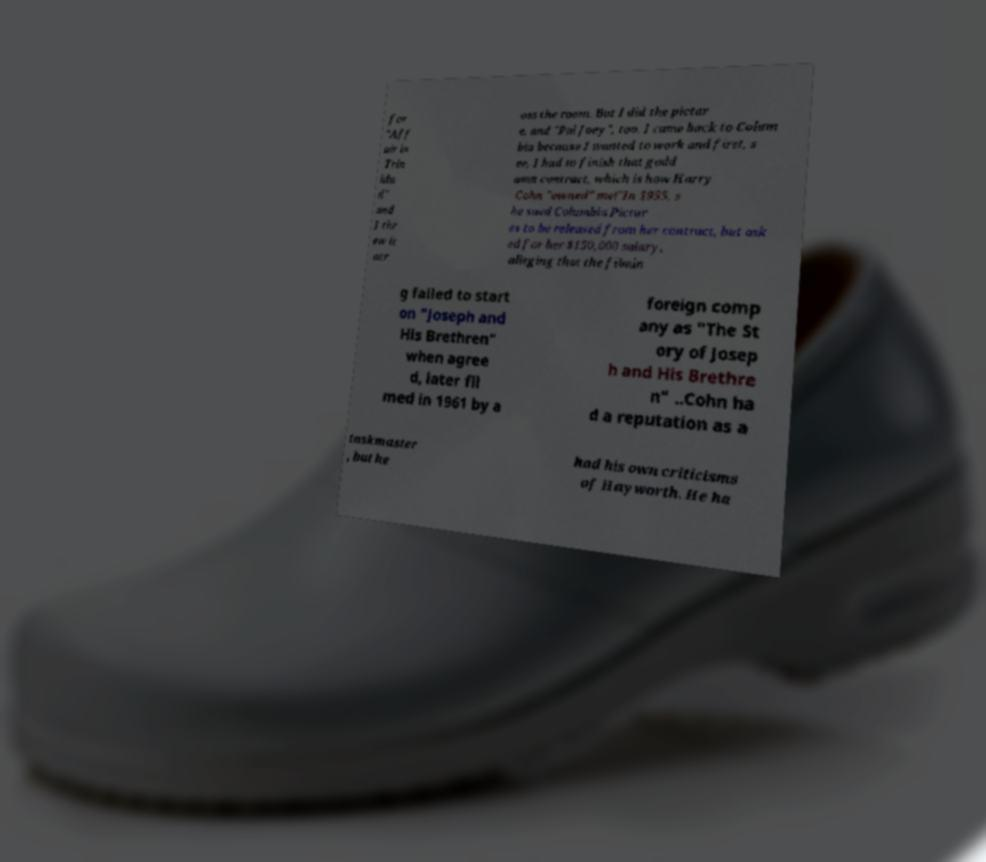For documentation purposes, I need the text within this image transcribed. Could you provide that? for "Aff air in Trin ida d" and I thr ew it acr oss the room. But I did the pictur e, and "Pal Joey", too. I came back to Colum bia because I wanted to work and first, s ee, I had to finish that godd amn contract, which is how Harry Cohn "owned" me!"In 1955, s he sued Columbia Pictur es to be released from her contract, but ask ed for her $150,000 salary, alleging that the filmin g failed to start on "Joseph and His Brethren" when agree d, later fil med in 1961 by a foreign comp any as "The St ory of Josep h and His Brethre n" ..Cohn ha d a reputation as a taskmaster , but he had his own criticisms of Hayworth. He ha 